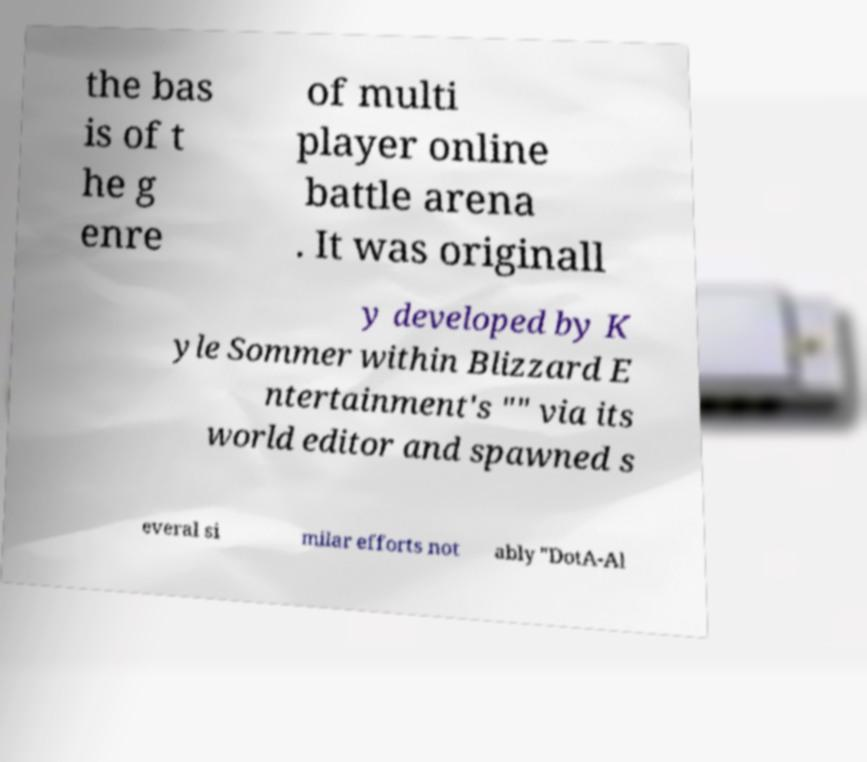Can you accurately transcribe the text from the provided image for me? the bas is of t he g enre of multi player online battle arena . It was originall y developed by K yle Sommer within Blizzard E ntertainment's "" via its world editor and spawned s everal si milar efforts not ably "DotA-Al 